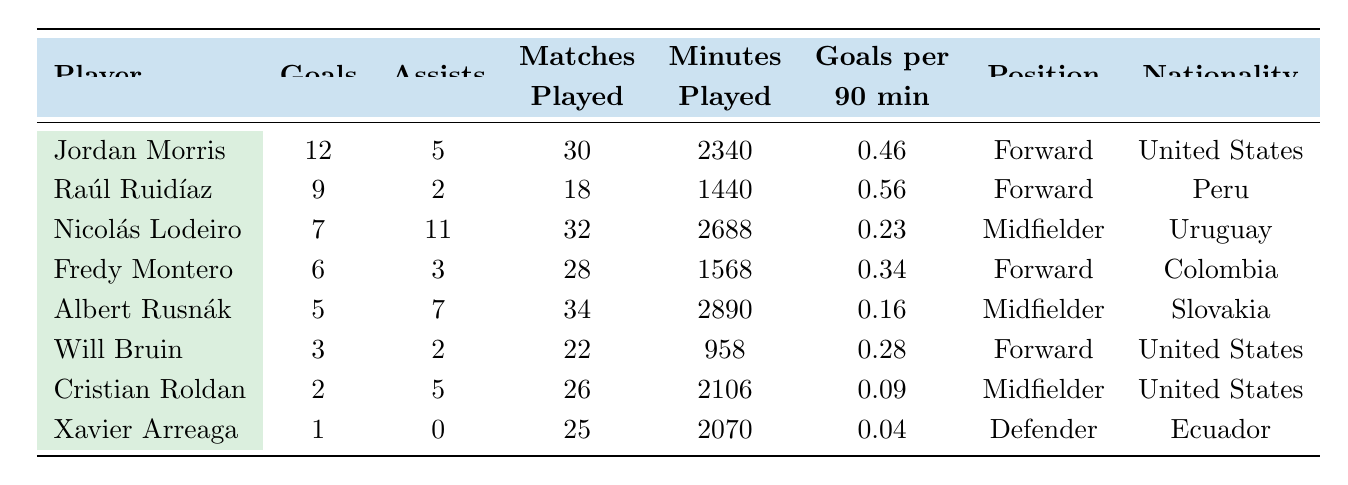What is the total number of goals scored by the top goal scorer, Jordan Morris? The table shows that Jordan Morris scored 12 goals in the 2022 season.
Answer: 12 Who had more assists, Nicolás Lodeiro or Fredy Montero? Nicolás Lodeiro had 11 assists while Fredy Montero had 3 assists, making Lodeiro the player with more assists.
Answer: Nicolás Lodeiro What is the goals per 90 minutes ratio for Raúl Ruidíaz? Raúl Ruidíaz scored 9 goals across 1440 minutes played. To find the goals per 90 minutes, calculate (9 goals / (1440 minutes / 90)) = 0.56.
Answer: 0.56 Which player had the highest goals per 90 minutes ratio? The highest goals per 90 minutes ratio is for Raúl Ruidíaz at 0.56, as shown in the table compared to the other players.
Answer: Raúl Ruidíaz What is the combined total of goals scored by both Will Bruin and Cristian Roldan? Will Bruin scored 3 goals and Cristian Roldan scored 2 goals, so the combined total is 3 + 2 = 5.
Answer: 5 Did any player score only one goal in the season? Yes, Xavier Arreaga scored only 1 goal in the 2022 season as detailed in the table.
Answer: Yes How many goals did the midfielders score in total? Midfielders in the table are Nicolás Lodeiro (7), Albert Rusnák (5), and Cristian Roldan (2). Their total goals are 7 + 5 + 2 = 14.
Answer: 14 If Jordan Morris had played 34 matches instead of 30, maintaining the same goals per 90, how many goals would he have scored? Jordan Morris has a goals per 90 minutes ratio of 0.46. If he had played 34 matches (3060 minutes), he would have scored (3060 min / 90) * 0.46 = 15.4 goals, rounding down gives us 15.
Answer: 15 How many goals did players with the Forward position score altogether? The forwards listed are Jordan Morris (12), Raúl Ruidíaz (9), Fredy Montero (6), and Will Bruin (3), totaling 12 + 9 + 6 + 3 = 30 goals.
Answer: 30 What percentage of matches did Jordan Morris play compared to the total matches played by Sounders players? Total matches played = 30 + 18 + 32 + 28 + 34 + 22 + 26 + 25 =  215. Jordan Morris played 30 matches. The percentage is (30 / 215) * 100 = 13.95%.
Answer: 13.95% 